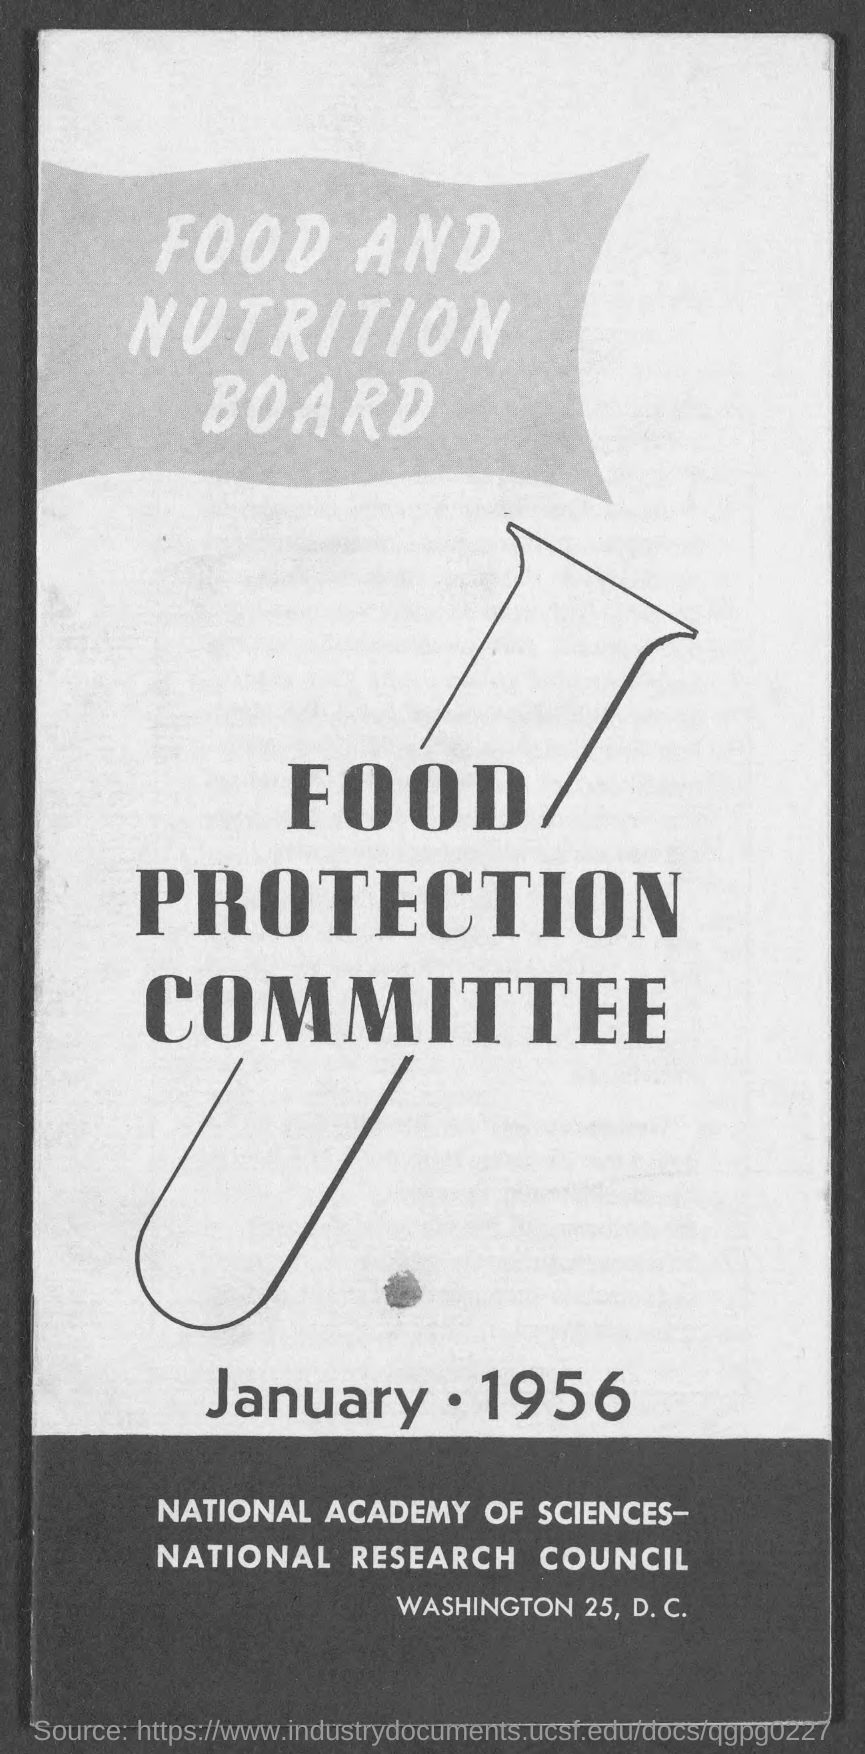Draw attention to some important aspects in this diagram. The FOOD PROTECTION COMMITTEE is mentioned in the document. 